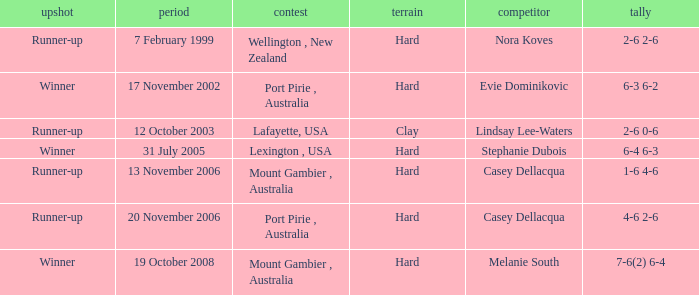Which Outcome has a Opponent of lindsay lee-waters? Runner-up. 